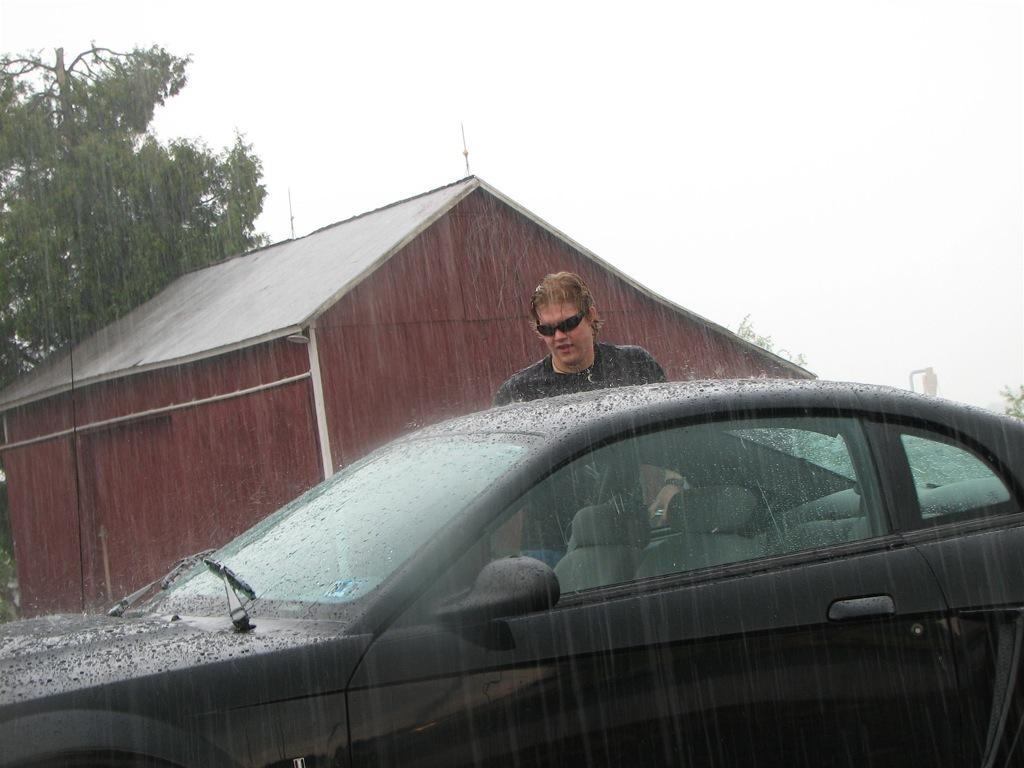What is the main subject of the image? There is a car in the image. Who or what is near the car? A man is standing behind the car. What can be seen in the distance in the image? There is a house and a tree in the background of the image. What is the weather like in the image? It is raining in the image. What type of behavior does the secretary exhibit in the image? There is no secretary present in the image. How low is the car in the image? The car is not described as being low or high in the image; it is simply a car. 